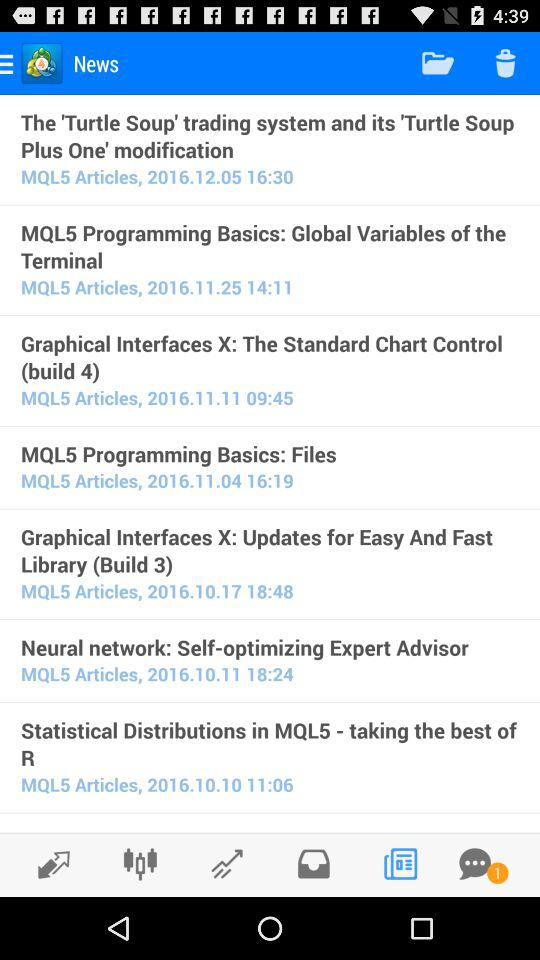What is the posted time of "Graphical Interfaces X: The Standard Chart Control (build 4)"? The posted time of "Graphical Interfaces X: The Standard Chart Control (build 4)" is 09:45. 